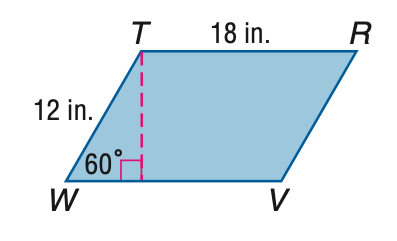Question: Find the perimeter of \parallelogram T R V W.
Choices:
A. 30
B. 48
C. 60
D. 72
Answer with the letter. Answer: C Question: Find the area of \parallelogram T R V W.
Choices:
A. 108
B. 108 \sqrt 2
C. 108 \sqrt 3
D. 216
Answer with the letter. Answer: C 